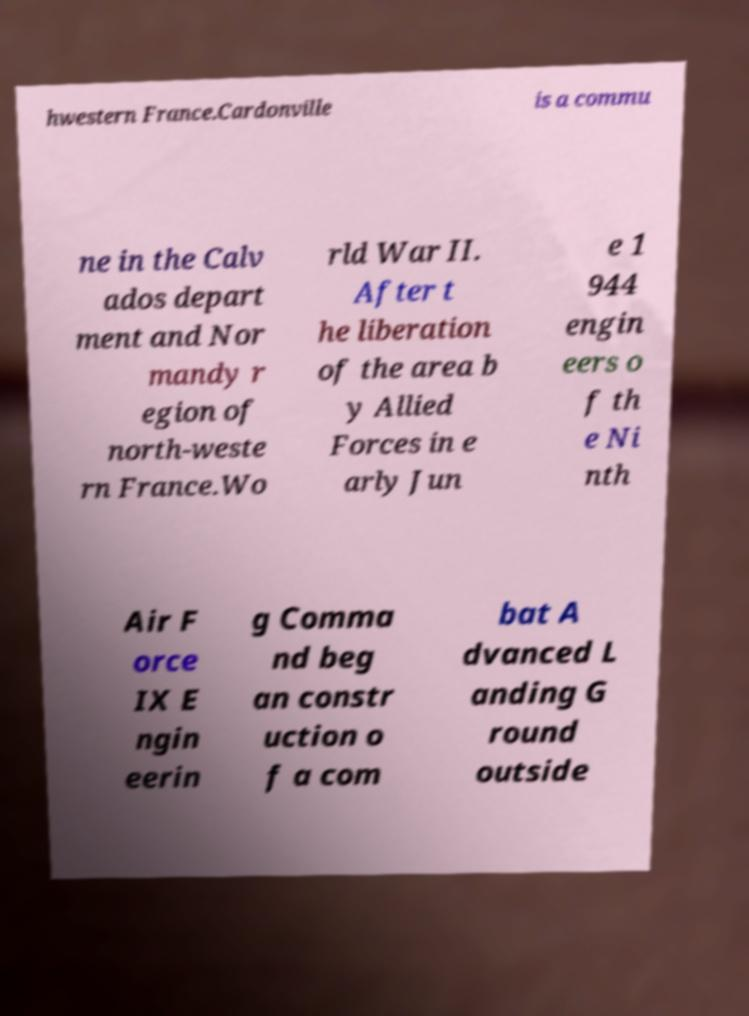Can you accurately transcribe the text from the provided image for me? hwestern France.Cardonville is a commu ne in the Calv ados depart ment and Nor mandy r egion of north-weste rn France.Wo rld War II. After t he liberation of the area b y Allied Forces in e arly Jun e 1 944 engin eers o f th e Ni nth Air F orce IX E ngin eerin g Comma nd beg an constr uction o f a com bat A dvanced L anding G round outside 